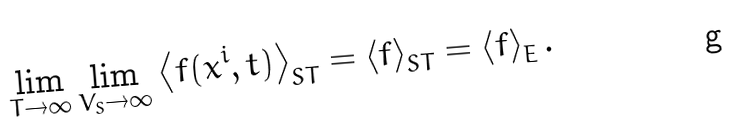<formula> <loc_0><loc_0><loc_500><loc_500>\lim _ { T \rightarrow \infty } \lim _ { V _ { S } \rightarrow \infty } \left \langle f ( x ^ { i } , t ) \right \rangle _ { S T } = \left \langle f \right \rangle _ { S T } = \left \langle f \right \rangle _ { E } .</formula> 